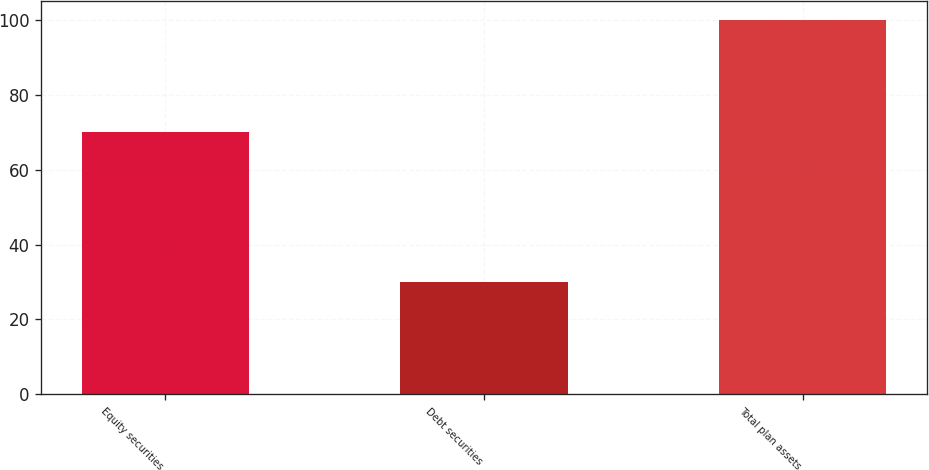Convert chart to OTSL. <chart><loc_0><loc_0><loc_500><loc_500><bar_chart><fcel>Equity securities<fcel>Debt securities<fcel>Total plan assets<nl><fcel>70<fcel>30<fcel>100<nl></chart> 